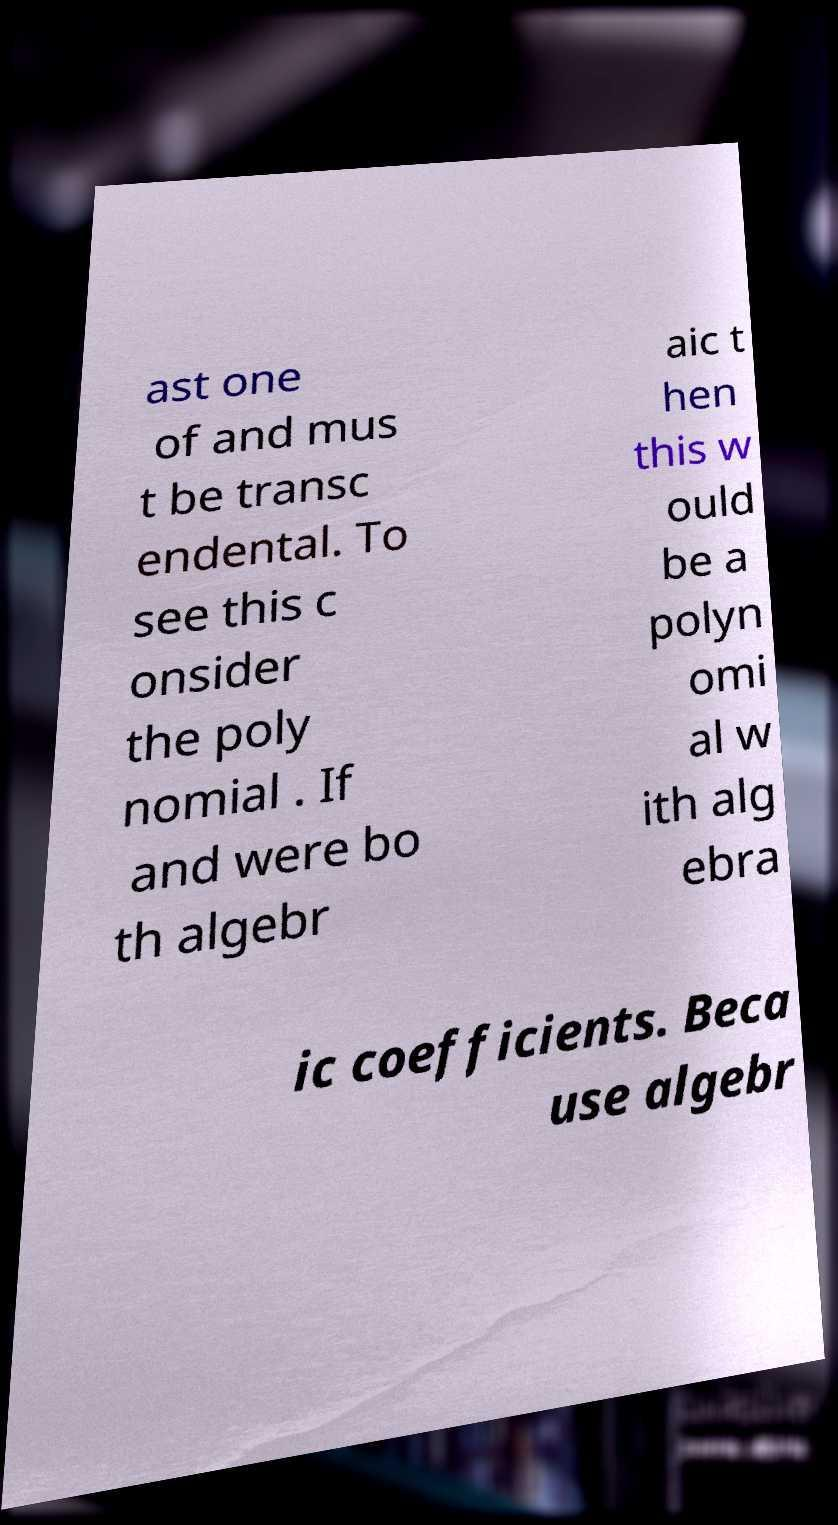What messages or text are displayed in this image? I need them in a readable, typed format. ast one of and mus t be transc endental. To see this c onsider the poly nomial . If and were bo th algebr aic t hen this w ould be a polyn omi al w ith alg ebra ic coefficients. Beca use algebr 